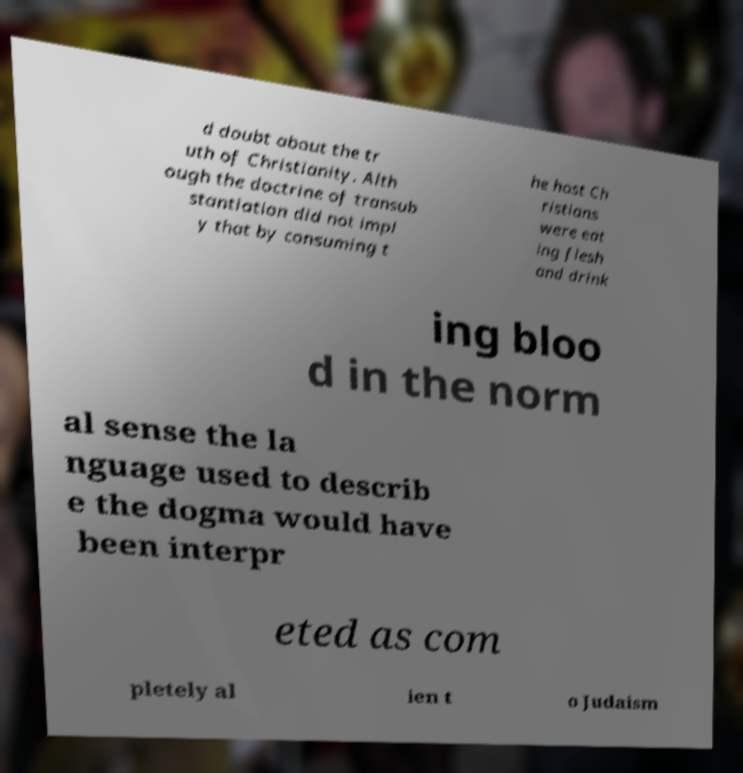Can you read and provide the text displayed in the image?This photo seems to have some interesting text. Can you extract and type it out for me? d doubt about the tr uth of Christianity. Alth ough the doctrine of transub stantiation did not impl y that by consuming t he host Ch ristians were eat ing flesh and drink ing bloo d in the norm al sense the la nguage used to describ e the dogma would have been interpr eted as com pletely al ien t o Judaism 